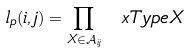<formula> <loc_0><loc_0><loc_500><loc_500>l _ { p } ( i , j ) = \prod _ { X \in \mathcal { A } _ { i j } } \ x T y p e { X }</formula> 